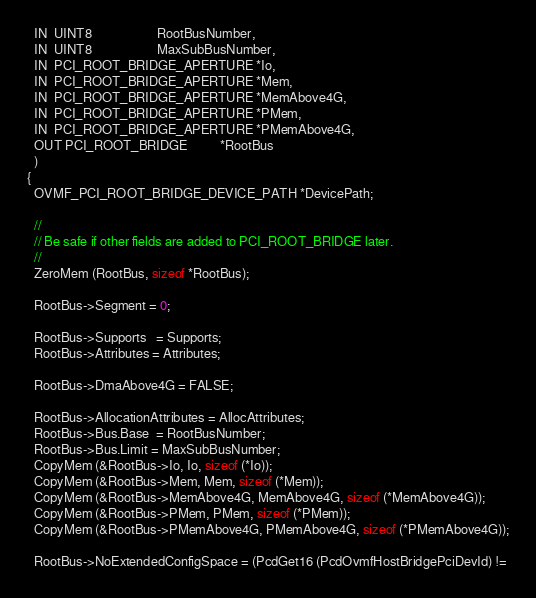<code> <loc_0><loc_0><loc_500><loc_500><_C_>  IN  UINT8                    RootBusNumber,
  IN  UINT8                    MaxSubBusNumber,
  IN  PCI_ROOT_BRIDGE_APERTURE *Io,
  IN  PCI_ROOT_BRIDGE_APERTURE *Mem,
  IN  PCI_ROOT_BRIDGE_APERTURE *MemAbove4G,
  IN  PCI_ROOT_BRIDGE_APERTURE *PMem,
  IN  PCI_ROOT_BRIDGE_APERTURE *PMemAbove4G,
  OUT PCI_ROOT_BRIDGE          *RootBus
  )
{
  OVMF_PCI_ROOT_BRIDGE_DEVICE_PATH *DevicePath;

  //
  // Be safe if other fields are added to PCI_ROOT_BRIDGE later.
  //
  ZeroMem (RootBus, sizeof *RootBus);

  RootBus->Segment = 0;

  RootBus->Supports   = Supports;
  RootBus->Attributes = Attributes;

  RootBus->DmaAbove4G = FALSE;

  RootBus->AllocationAttributes = AllocAttributes;
  RootBus->Bus.Base  = RootBusNumber;
  RootBus->Bus.Limit = MaxSubBusNumber;
  CopyMem (&RootBus->Io, Io, sizeof (*Io));
  CopyMem (&RootBus->Mem, Mem, sizeof (*Mem));
  CopyMem (&RootBus->MemAbove4G, MemAbove4G, sizeof (*MemAbove4G));
  CopyMem (&RootBus->PMem, PMem, sizeof (*PMem));
  CopyMem (&RootBus->PMemAbove4G, PMemAbove4G, sizeof (*PMemAbove4G));

  RootBus->NoExtendedConfigSpace = (PcdGet16 (PcdOvmfHostBridgePciDevId) !=</code> 